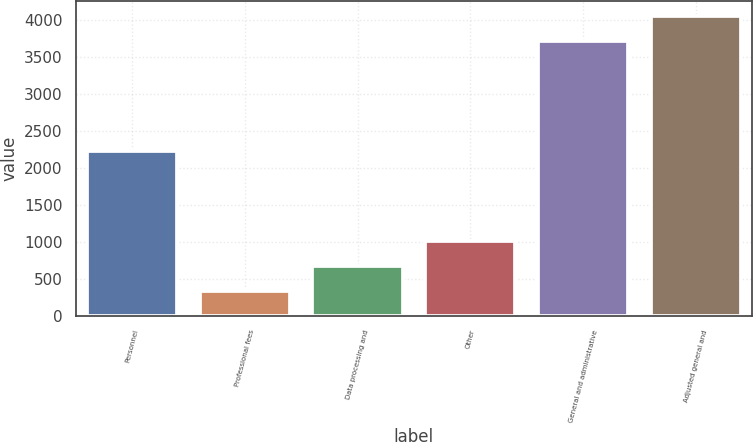Convert chart to OTSL. <chart><loc_0><loc_0><loc_500><loc_500><bar_chart><fcel>Personnel<fcel>Professional fees<fcel>Data processing and<fcel>Other<fcel>General and administrative<fcel>Adjusted general and<nl><fcel>2225<fcel>337<fcel>674.7<fcel>1012.4<fcel>3714<fcel>4051.7<nl></chart> 